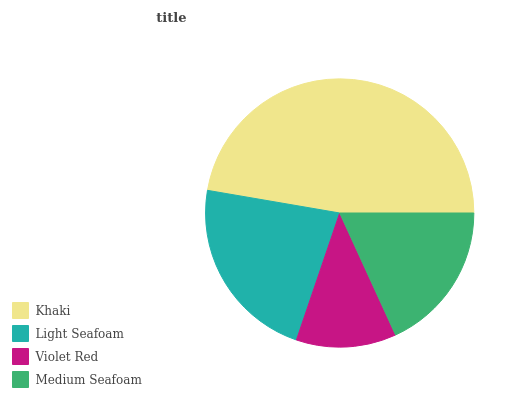Is Violet Red the minimum?
Answer yes or no. Yes. Is Khaki the maximum?
Answer yes or no. Yes. Is Light Seafoam the minimum?
Answer yes or no. No. Is Light Seafoam the maximum?
Answer yes or no. No. Is Khaki greater than Light Seafoam?
Answer yes or no. Yes. Is Light Seafoam less than Khaki?
Answer yes or no. Yes. Is Light Seafoam greater than Khaki?
Answer yes or no. No. Is Khaki less than Light Seafoam?
Answer yes or no. No. Is Light Seafoam the high median?
Answer yes or no. Yes. Is Medium Seafoam the low median?
Answer yes or no. Yes. Is Khaki the high median?
Answer yes or no. No. Is Khaki the low median?
Answer yes or no. No. 